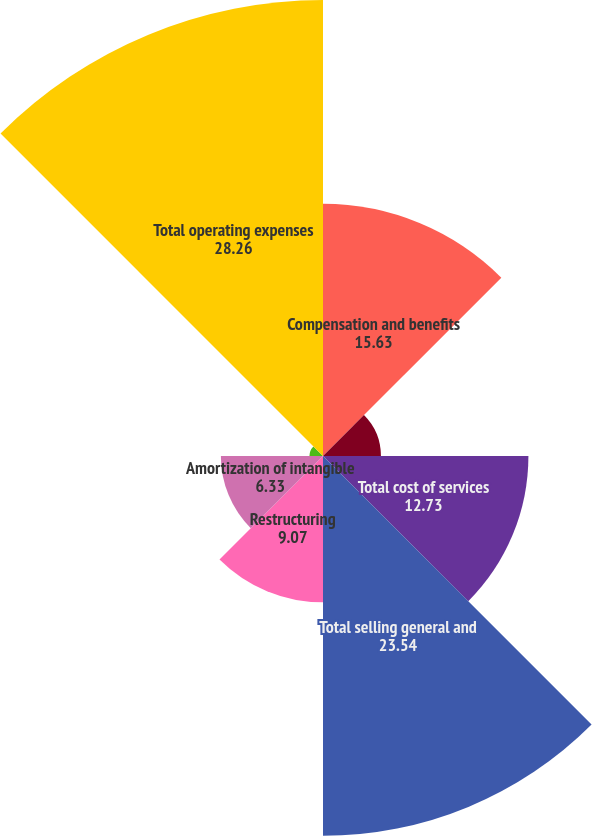<chart> <loc_0><loc_0><loc_500><loc_500><pie_chart><fcel>Compensation and benefits<fcel>Non-compensation expenses<fcel>Total cost of services<fcel>Total selling general and<fcel>Restructuring<fcel>Amortization of intangible<fcel>Depreciation of property<fcel>Total operating expenses<nl><fcel>15.63%<fcel>3.59%<fcel>12.73%<fcel>23.54%<fcel>9.07%<fcel>6.33%<fcel>0.84%<fcel>28.26%<nl></chart> 